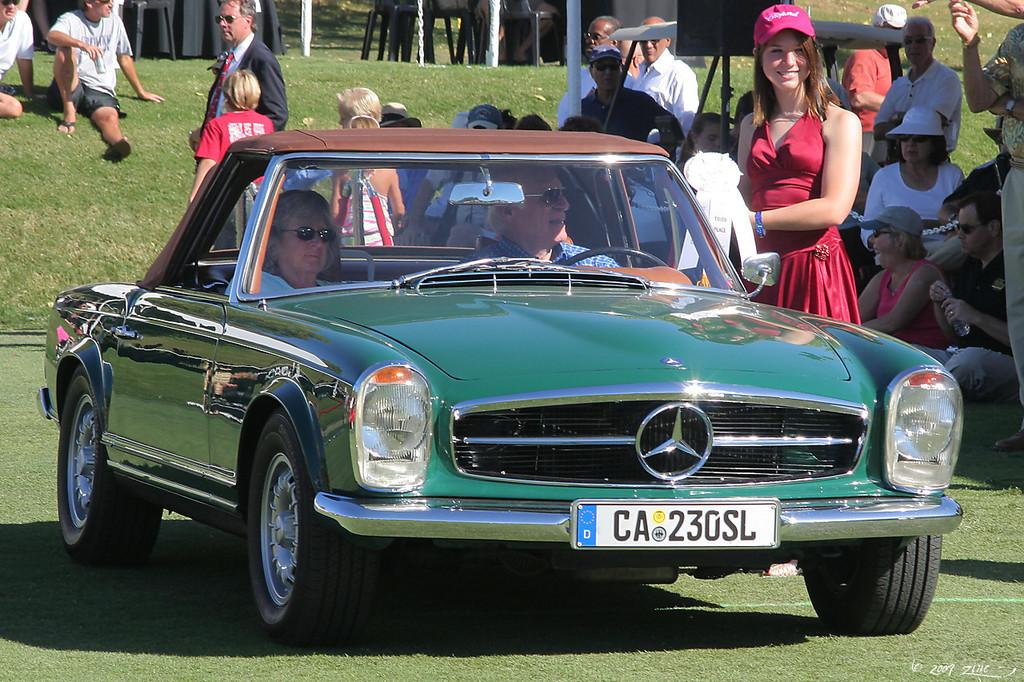What is the main subject of the image? There is a car in the image. Who is inside the car? Two persons are sitting in the car. What can be seen in the background of the image? There are people sitting on the ground in the background of the image. What type of spiders can be seen crawling on the car in the image? There are no spiders present in the image; it features a car with two people sitting inside and other people sitting on the ground in the background. 